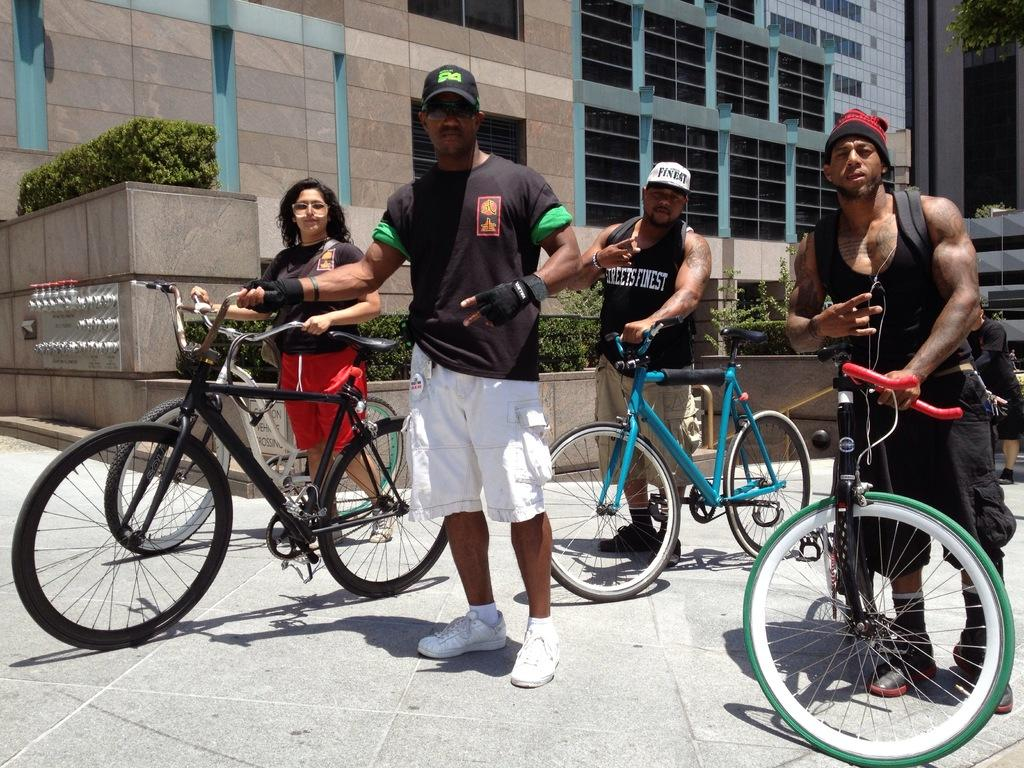What are the people in the image holding? The people in the image are holding bicycles. What can be seen in the background of the image? There is a building in the background of the image. What type of natural elements are present in the image? Plants are present in the image. Can you hear the rhythm of the waves crashing on the seashore in the image? There is no seashore or sound of waves in the image; it features people holding bicycles and a building in the background. 